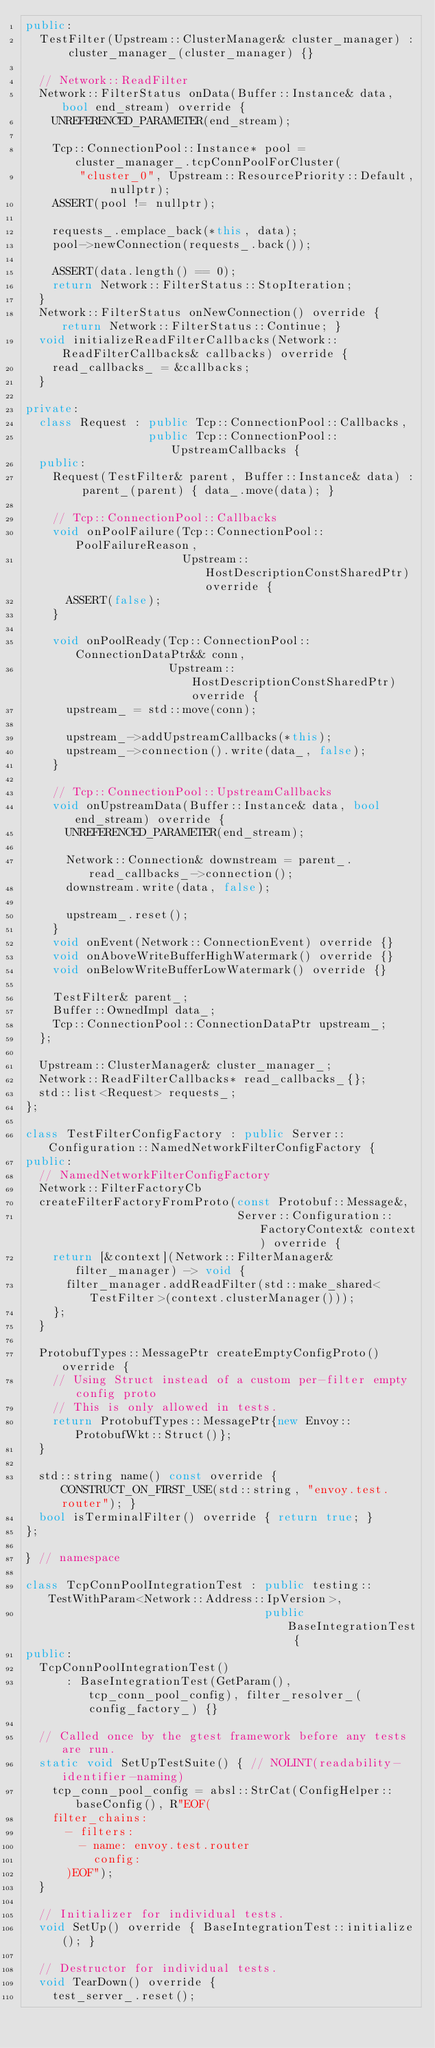Convert code to text. <code><loc_0><loc_0><loc_500><loc_500><_C++_>public:
  TestFilter(Upstream::ClusterManager& cluster_manager) : cluster_manager_(cluster_manager) {}

  // Network::ReadFilter
  Network::FilterStatus onData(Buffer::Instance& data, bool end_stream) override {
    UNREFERENCED_PARAMETER(end_stream);

    Tcp::ConnectionPool::Instance* pool = cluster_manager_.tcpConnPoolForCluster(
        "cluster_0", Upstream::ResourcePriority::Default, nullptr);
    ASSERT(pool != nullptr);

    requests_.emplace_back(*this, data);
    pool->newConnection(requests_.back());

    ASSERT(data.length() == 0);
    return Network::FilterStatus::StopIteration;
  }
  Network::FilterStatus onNewConnection() override { return Network::FilterStatus::Continue; }
  void initializeReadFilterCallbacks(Network::ReadFilterCallbacks& callbacks) override {
    read_callbacks_ = &callbacks;
  }

private:
  class Request : public Tcp::ConnectionPool::Callbacks,
                  public Tcp::ConnectionPool::UpstreamCallbacks {
  public:
    Request(TestFilter& parent, Buffer::Instance& data) : parent_(parent) { data_.move(data); }

    // Tcp::ConnectionPool::Callbacks
    void onPoolFailure(Tcp::ConnectionPool::PoolFailureReason,
                       Upstream::HostDescriptionConstSharedPtr) override {
      ASSERT(false);
    }

    void onPoolReady(Tcp::ConnectionPool::ConnectionDataPtr&& conn,
                     Upstream::HostDescriptionConstSharedPtr) override {
      upstream_ = std::move(conn);

      upstream_->addUpstreamCallbacks(*this);
      upstream_->connection().write(data_, false);
    }

    // Tcp::ConnectionPool::UpstreamCallbacks
    void onUpstreamData(Buffer::Instance& data, bool end_stream) override {
      UNREFERENCED_PARAMETER(end_stream);

      Network::Connection& downstream = parent_.read_callbacks_->connection();
      downstream.write(data, false);

      upstream_.reset();
    }
    void onEvent(Network::ConnectionEvent) override {}
    void onAboveWriteBufferHighWatermark() override {}
    void onBelowWriteBufferLowWatermark() override {}

    TestFilter& parent_;
    Buffer::OwnedImpl data_;
    Tcp::ConnectionPool::ConnectionDataPtr upstream_;
  };

  Upstream::ClusterManager& cluster_manager_;
  Network::ReadFilterCallbacks* read_callbacks_{};
  std::list<Request> requests_;
};

class TestFilterConfigFactory : public Server::Configuration::NamedNetworkFilterConfigFactory {
public:
  // NamedNetworkFilterConfigFactory
  Network::FilterFactoryCb
  createFilterFactoryFromProto(const Protobuf::Message&,
                               Server::Configuration::FactoryContext& context) override {
    return [&context](Network::FilterManager& filter_manager) -> void {
      filter_manager.addReadFilter(std::make_shared<TestFilter>(context.clusterManager()));
    };
  }

  ProtobufTypes::MessagePtr createEmptyConfigProto() override {
    // Using Struct instead of a custom per-filter empty config proto
    // This is only allowed in tests.
    return ProtobufTypes::MessagePtr{new Envoy::ProtobufWkt::Struct()};
  }

  std::string name() const override { CONSTRUCT_ON_FIRST_USE(std::string, "envoy.test.router"); }
  bool isTerminalFilter() override { return true; }
};

} // namespace

class TcpConnPoolIntegrationTest : public testing::TestWithParam<Network::Address::IpVersion>,
                                   public BaseIntegrationTest {
public:
  TcpConnPoolIntegrationTest()
      : BaseIntegrationTest(GetParam(), tcp_conn_pool_config), filter_resolver_(config_factory_) {}

  // Called once by the gtest framework before any tests are run.
  static void SetUpTestSuite() { // NOLINT(readability-identifier-naming)
    tcp_conn_pool_config = absl::StrCat(ConfigHelper::baseConfig(), R"EOF(
    filter_chains:
      - filters:
        - name: envoy.test.router
          config:
      )EOF");
  }

  // Initializer for individual tests.
  void SetUp() override { BaseIntegrationTest::initialize(); }

  // Destructor for individual tests.
  void TearDown() override {
    test_server_.reset();</code> 